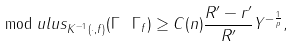<formula> <loc_0><loc_0><loc_500><loc_500>\mod u l u s _ { K ^ { - 1 } ( \cdot , f ) } ( \Gamma \ \Gamma _ { f } ) \geq C ( n ) \frac { R ^ { \prime } - r ^ { \prime } } { R ^ { \prime } } Y ^ { - \frac { 1 } { p } } ,</formula> 